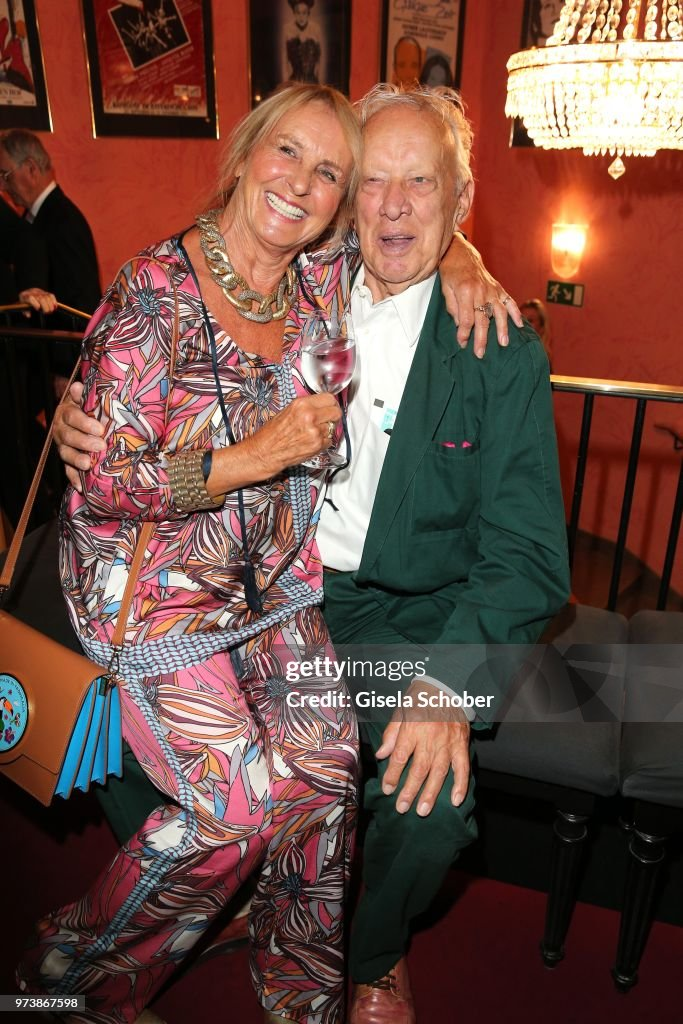What can we infer about the event based on the background elements? The background elements, including the posters and the chandelier, suggest that the event is taking place in a cultural or entertainment venue, possibly a theater or an art gallery. The elegant chandelier and the framed posters indicate a touch of sophistication and a celebration of the arts. This setting, combined with the relaxed and joyful appearance of the couple, implies that the event could be a social gathering centered around a cultural or artistic theme, likely attended by individuals who appreciate such environments. Can you imagine a conversation they might be having right now? Given their broad smiles and relaxed posture, it's likely they are reminiscing about a shared memory or discussing the performances or artworks around them. The conversation might be filled with warmth and laughter as they recall funny anecdotes or marvel at the talented individuals showcased in the posters. They might be saying something like, 'Do you remember the time we first saw that play? It was so hilarious!' or 'The artist behind that painting has such a unique style. Truly captivating!' This evocative setting and their evident comfort with each other hint at a deep, shared history. 